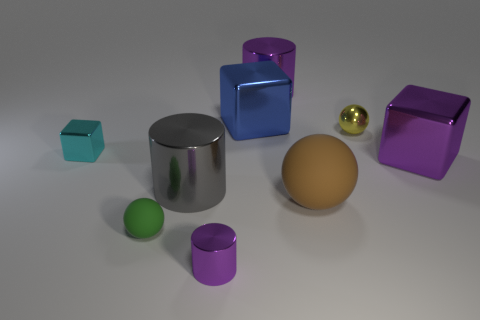There is a brown object that is made of the same material as the green object; what is its shape?
Give a very brief answer. Sphere. Is there any other thing that is the same shape as the gray thing?
Your answer should be very brief. Yes. Does the tiny ball that is left of the large brown sphere have the same material as the large blue cube?
Make the answer very short. No. There is a sphere in front of the brown matte thing; what is it made of?
Make the answer very short. Rubber. How big is the block that is behind the ball that is on the right side of the big brown ball?
Give a very brief answer. Large. How many brown spheres are the same size as the blue cube?
Your response must be concise. 1. There is a large metallic object that is behind the large blue block; is it the same color as the sphere that is left of the gray shiny object?
Offer a very short reply. No. There is a cyan block; are there any big blocks behind it?
Your response must be concise. Yes. The metallic object that is in front of the tiny cyan thing and right of the tiny purple metal cylinder is what color?
Provide a succinct answer. Purple. Are there any big metallic objects that have the same color as the small shiny ball?
Your answer should be very brief. No. 